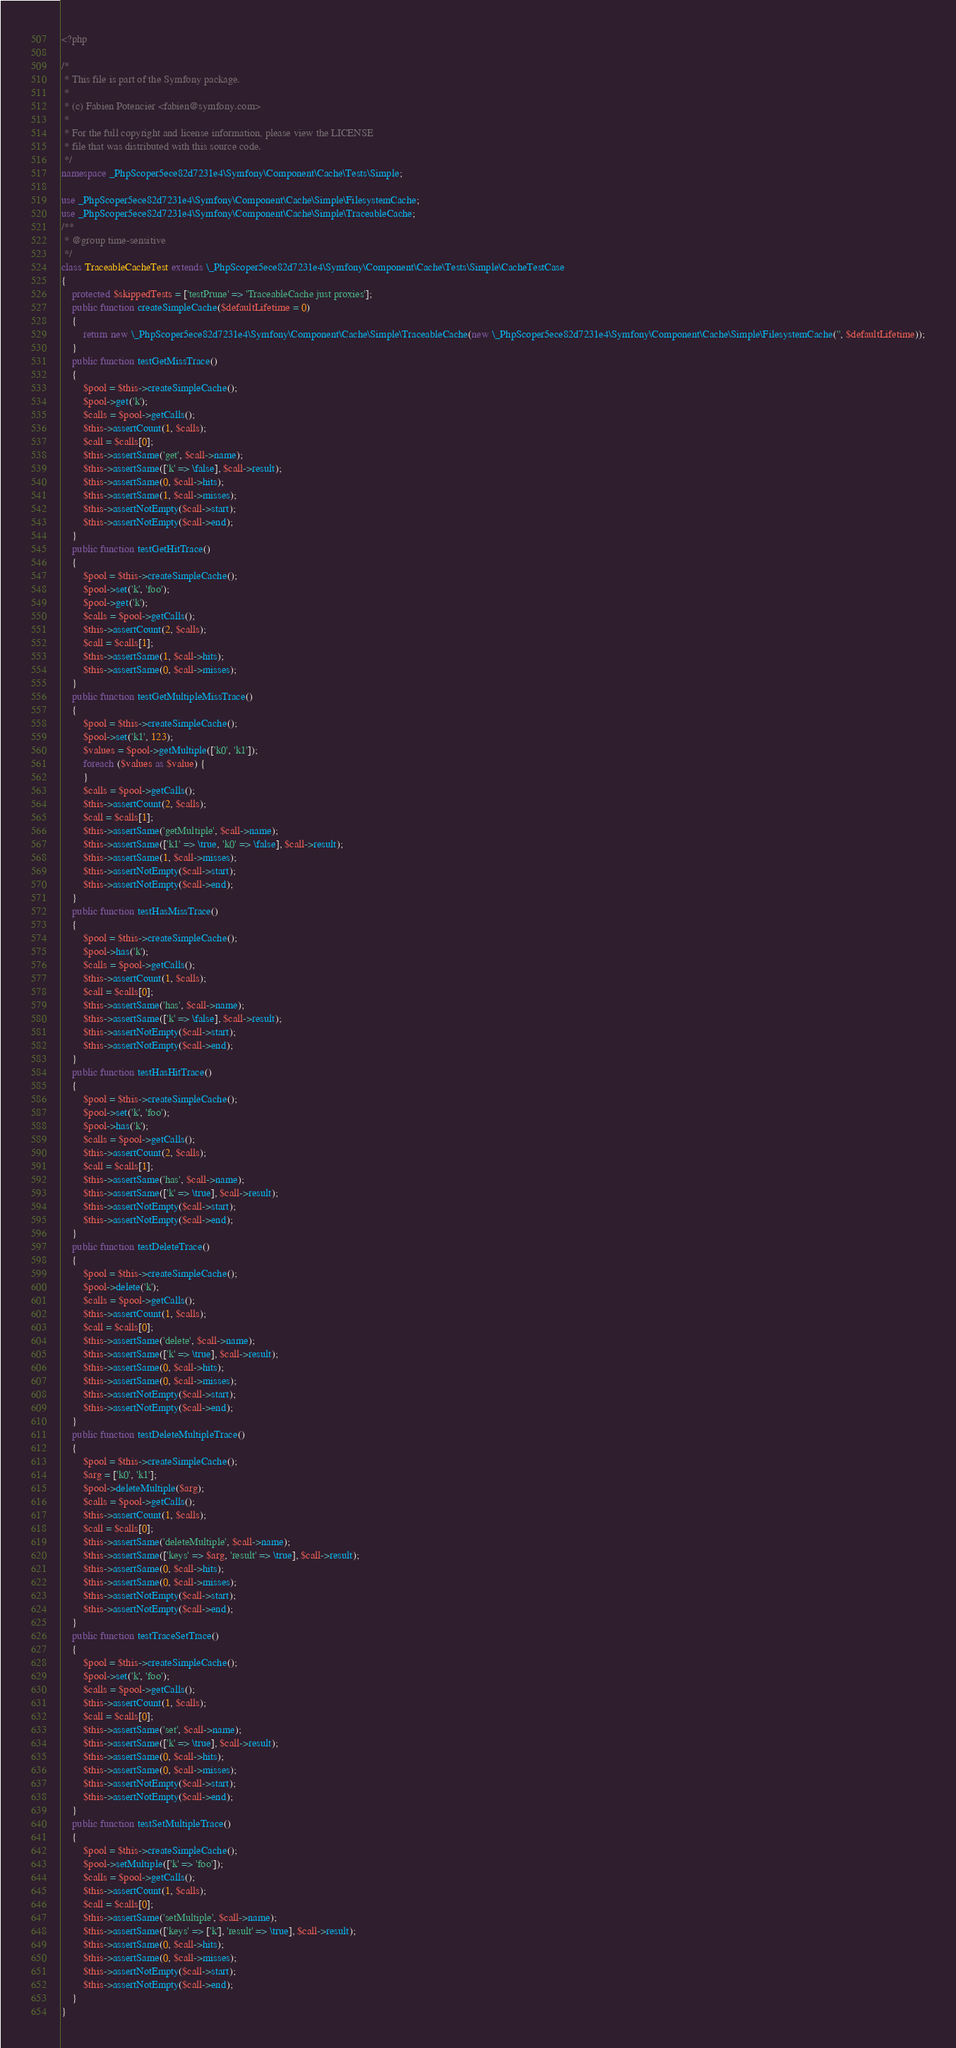Convert code to text. <code><loc_0><loc_0><loc_500><loc_500><_PHP_><?php

/*
 * This file is part of the Symfony package.
 *
 * (c) Fabien Potencier <fabien@symfony.com>
 *
 * For the full copyright and license information, please view the LICENSE
 * file that was distributed with this source code.
 */
namespace _PhpScoper5ece82d7231e4\Symfony\Component\Cache\Tests\Simple;

use _PhpScoper5ece82d7231e4\Symfony\Component\Cache\Simple\FilesystemCache;
use _PhpScoper5ece82d7231e4\Symfony\Component\Cache\Simple\TraceableCache;
/**
 * @group time-sensitive
 */
class TraceableCacheTest extends \_PhpScoper5ece82d7231e4\Symfony\Component\Cache\Tests\Simple\CacheTestCase
{
    protected $skippedTests = ['testPrune' => 'TraceableCache just proxies'];
    public function createSimpleCache($defaultLifetime = 0)
    {
        return new \_PhpScoper5ece82d7231e4\Symfony\Component\Cache\Simple\TraceableCache(new \_PhpScoper5ece82d7231e4\Symfony\Component\Cache\Simple\FilesystemCache('', $defaultLifetime));
    }
    public function testGetMissTrace()
    {
        $pool = $this->createSimpleCache();
        $pool->get('k');
        $calls = $pool->getCalls();
        $this->assertCount(1, $calls);
        $call = $calls[0];
        $this->assertSame('get', $call->name);
        $this->assertSame(['k' => \false], $call->result);
        $this->assertSame(0, $call->hits);
        $this->assertSame(1, $call->misses);
        $this->assertNotEmpty($call->start);
        $this->assertNotEmpty($call->end);
    }
    public function testGetHitTrace()
    {
        $pool = $this->createSimpleCache();
        $pool->set('k', 'foo');
        $pool->get('k');
        $calls = $pool->getCalls();
        $this->assertCount(2, $calls);
        $call = $calls[1];
        $this->assertSame(1, $call->hits);
        $this->assertSame(0, $call->misses);
    }
    public function testGetMultipleMissTrace()
    {
        $pool = $this->createSimpleCache();
        $pool->set('k1', 123);
        $values = $pool->getMultiple(['k0', 'k1']);
        foreach ($values as $value) {
        }
        $calls = $pool->getCalls();
        $this->assertCount(2, $calls);
        $call = $calls[1];
        $this->assertSame('getMultiple', $call->name);
        $this->assertSame(['k1' => \true, 'k0' => \false], $call->result);
        $this->assertSame(1, $call->misses);
        $this->assertNotEmpty($call->start);
        $this->assertNotEmpty($call->end);
    }
    public function testHasMissTrace()
    {
        $pool = $this->createSimpleCache();
        $pool->has('k');
        $calls = $pool->getCalls();
        $this->assertCount(1, $calls);
        $call = $calls[0];
        $this->assertSame('has', $call->name);
        $this->assertSame(['k' => \false], $call->result);
        $this->assertNotEmpty($call->start);
        $this->assertNotEmpty($call->end);
    }
    public function testHasHitTrace()
    {
        $pool = $this->createSimpleCache();
        $pool->set('k', 'foo');
        $pool->has('k');
        $calls = $pool->getCalls();
        $this->assertCount(2, $calls);
        $call = $calls[1];
        $this->assertSame('has', $call->name);
        $this->assertSame(['k' => \true], $call->result);
        $this->assertNotEmpty($call->start);
        $this->assertNotEmpty($call->end);
    }
    public function testDeleteTrace()
    {
        $pool = $this->createSimpleCache();
        $pool->delete('k');
        $calls = $pool->getCalls();
        $this->assertCount(1, $calls);
        $call = $calls[0];
        $this->assertSame('delete', $call->name);
        $this->assertSame(['k' => \true], $call->result);
        $this->assertSame(0, $call->hits);
        $this->assertSame(0, $call->misses);
        $this->assertNotEmpty($call->start);
        $this->assertNotEmpty($call->end);
    }
    public function testDeleteMultipleTrace()
    {
        $pool = $this->createSimpleCache();
        $arg = ['k0', 'k1'];
        $pool->deleteMultiple($arg);
        $calls = $pool->getCalls();
        $this->assertCount(1, $calls);
        $call = $calls[0];
        $this->assertSame('deleteMultiple', $call->name);
        $this->assertSame(['keys' => $arg, 'result' => \true], $call->result);
        $this->assertSame(0, $call->hits);
        $this->assertSame(0, $call->misses);
        $this->assertNotEmpty($call->start);
        $this->assertNotEmpty($call->end);
    }
    public function testTraceSetTrace()
    {
        $pool = $this->createSimpleCache();
        $pool->set('k', 'foo');
        $calls = $pool->getCalls();
        $this->assertCount(1, $calls);
        $call = $calls[0];
        $this->assertSame('set', $call->name);
        $this->assertSame(['k' => \true], $call->result);
        $this->assertSame(0, $call->hits);
        $this->assertSame(0, $call->misses);
        $this->assertNotEmpty($call->start);
        $this->assertNotEmpty($call->end);
    }
    public function testSetMultipleTrace()
    {
        $pool = $this->createSimpleCache();
        $pool->setMultiple(['k' => 'foo']);
        $calls = $pool->getCalls();
        $this->assertCount(1, $calls);
        $call = $calls[0];
        $this->assertSame('setMultiple', $call->name);
        $this->assertSame(['keys' => ['k'], 'result' => \true], $call->result);
        $this->assertSame(0, $call->hits);
        $this->assertSame(0, $call->misses);
        $this->assertNotEmpty($call->start);
        $this->assertNotEmpty($call->end);
    }
}
</code> 